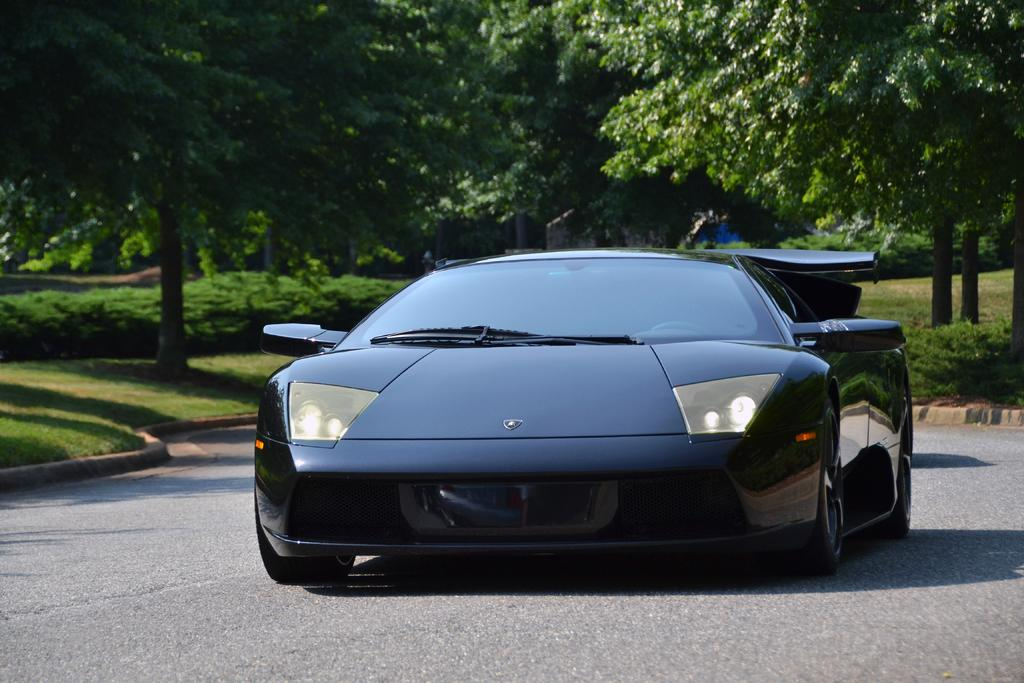What is the main subject of the image? There is a car on the road in the image. What can be seen in the background of the image? There is grass, plants, trees, and a house in the background of the image. How many geese are flying over the car in the image? There are no geese present in the image; it only features a car on the road and the background elements mentioned earlier. 